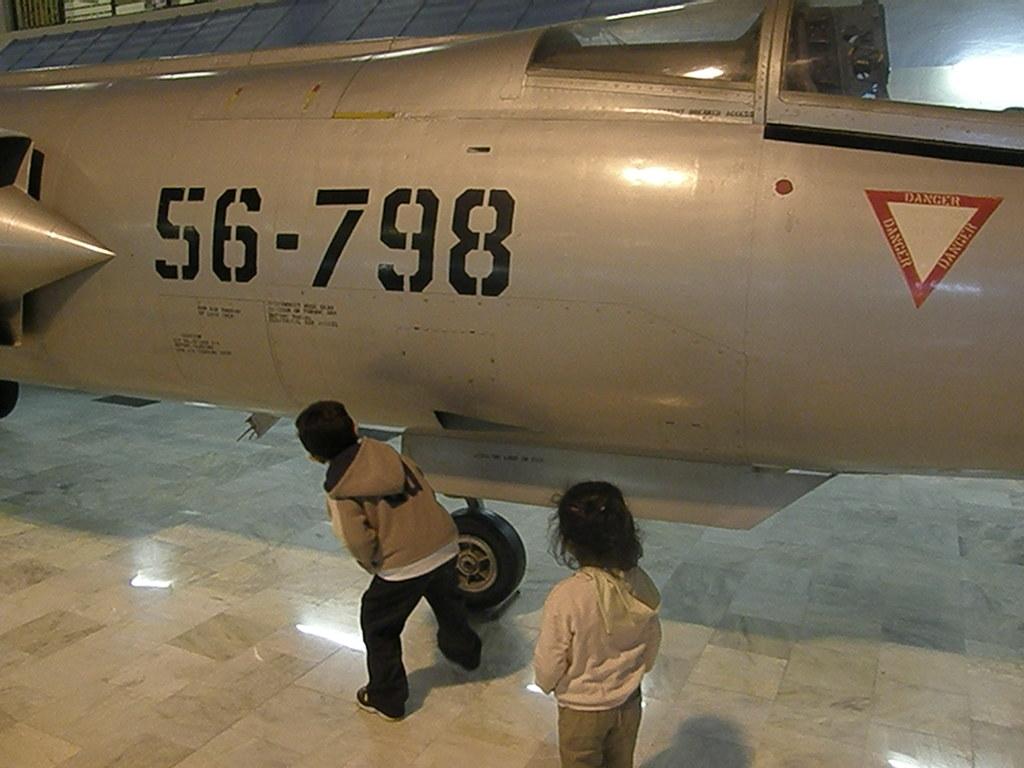What is the aircraft number?
Keep it short and to the point. 56-798. What does the text say in the triangle?
Give a very brief answer. Danger. 